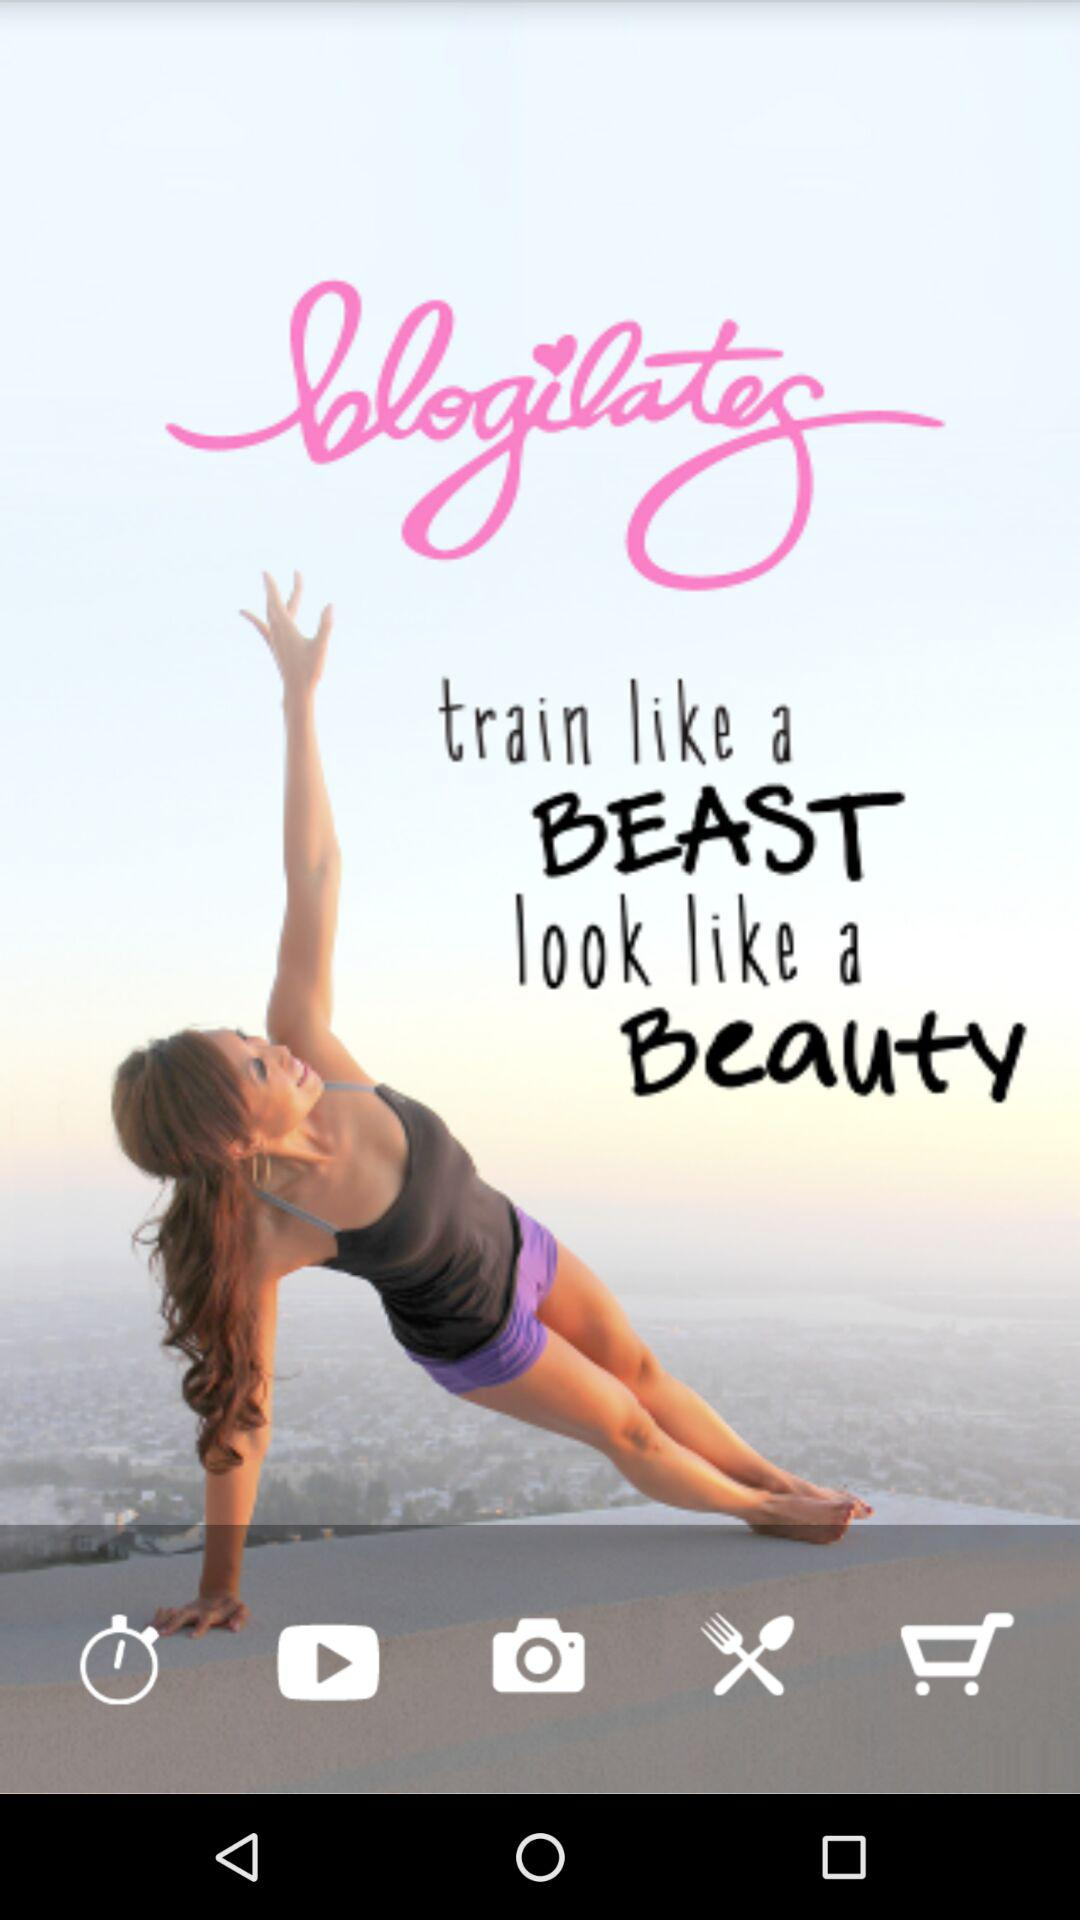What is the name of the application? The name of the application is "blogilates". 